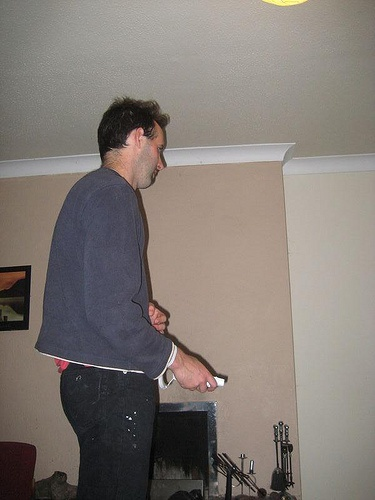Describe the objects in this image and their specific colors. I can see people in gray, black, and salmon tones and remote in gray, white, and darkgray tones in this image. 